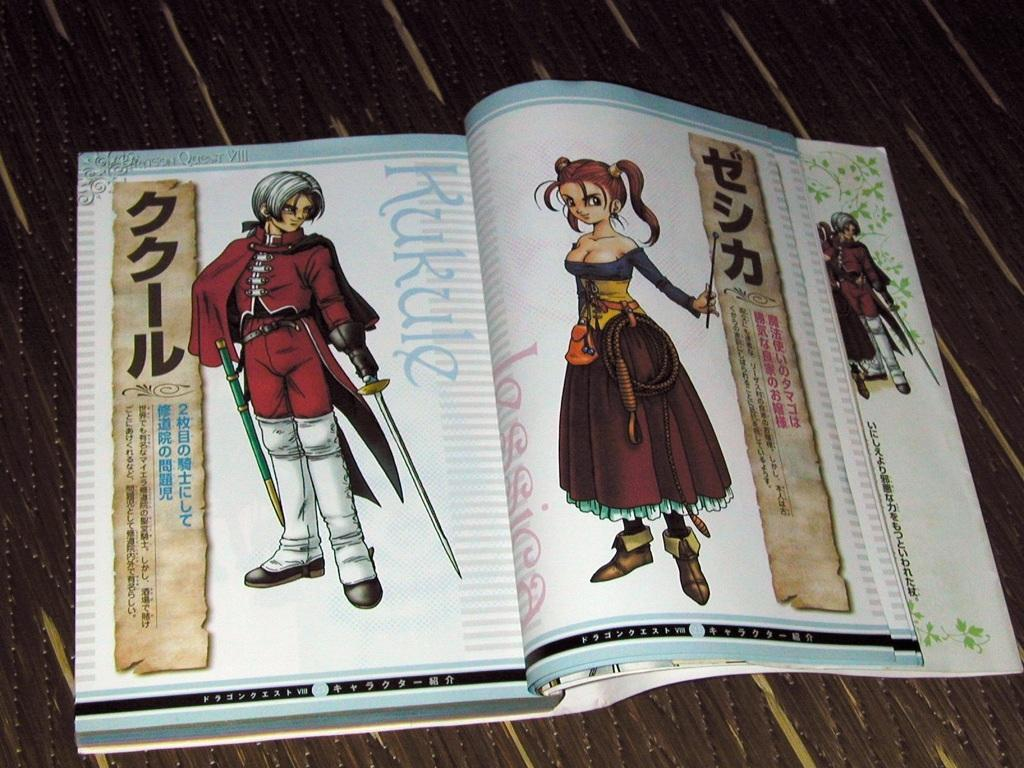<image>
Share a concise interpretation of the image provided. A japanese book with a character named Kukule. 